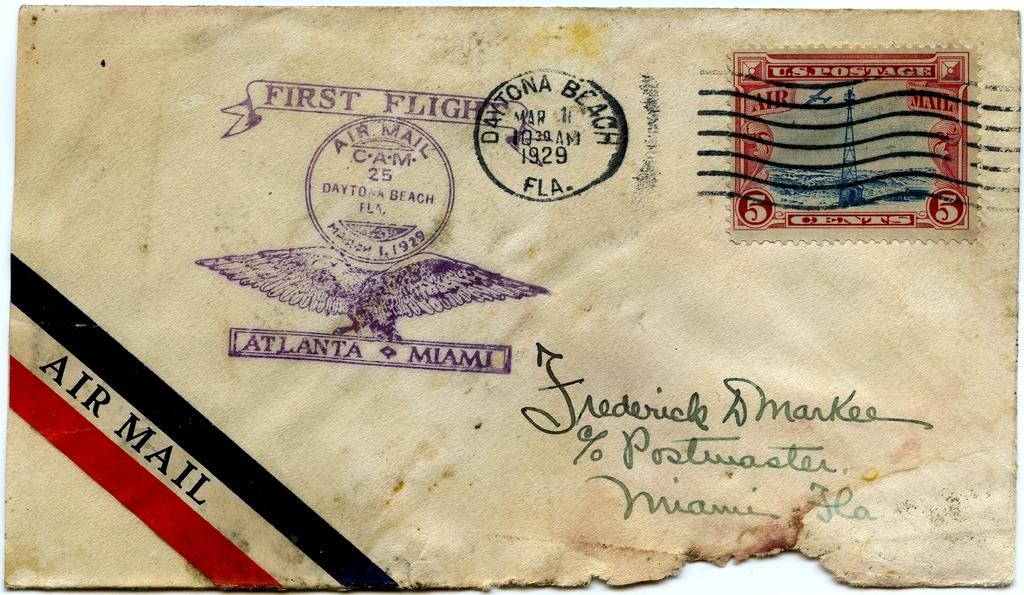Provide a one-sentence caption for the provided image. Air Mail first flight from Atlanta to Miami is stamped on this envelope. 